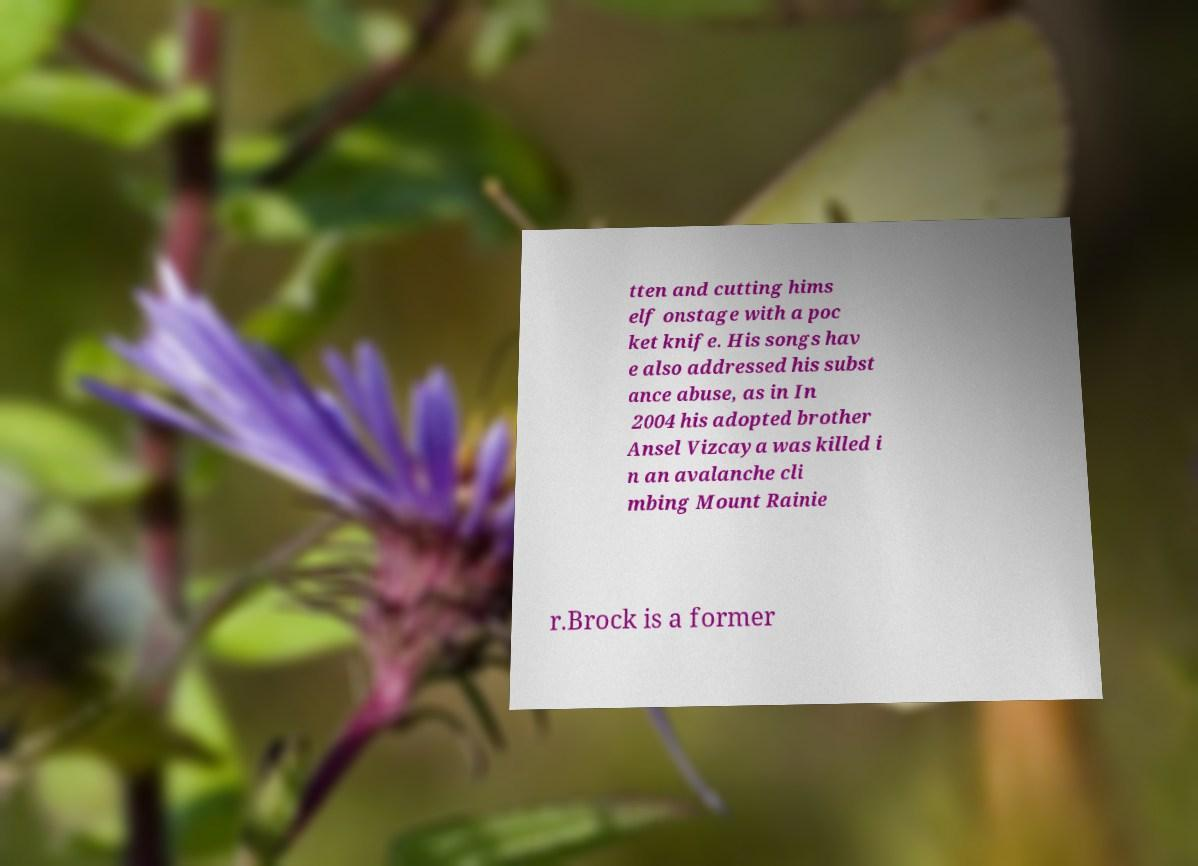There's text embedded in this image that I need extracted. Can you transcribe it verbatim? tten and cutting hims elf onstage with a poc ket knife. His songs hav e also addressed his subst ance abuse, as in In 2004 his adopted brother Ansel Vizcaya was killed i n an avalanche cli mbing Mount Rainie r.Brock is a former 